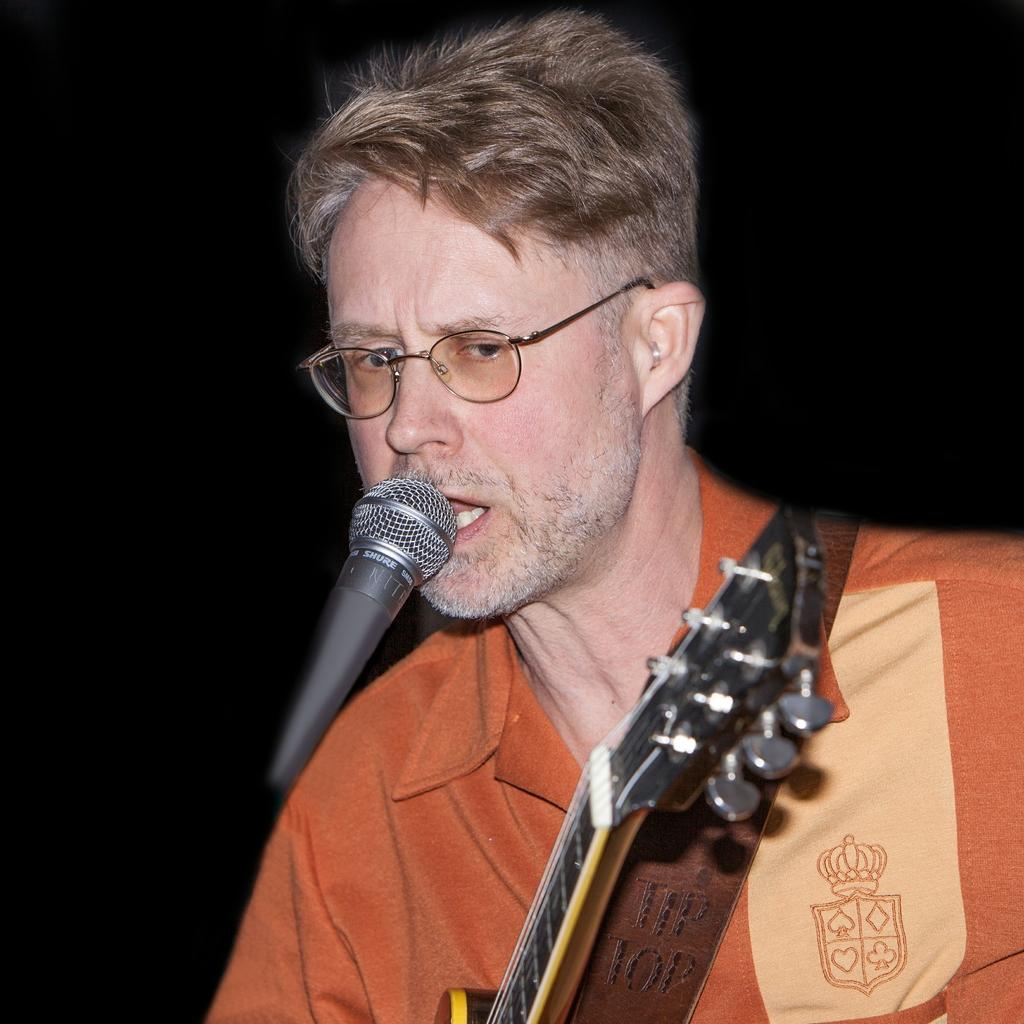How many people are in the image? There is one person in the image. What is the person wearing? The person is wearing an orange t-shirt. What is the person holding? The person is holding a guitar. What activity is the person engaged in? The person is singing in front of a microphone. What type of accessory is the person wearing? The person is wearing glasses. What type of soup is the person eating in the image? There is no soup present in the image; the person is holding a guitar and singing in front of a microphone. 